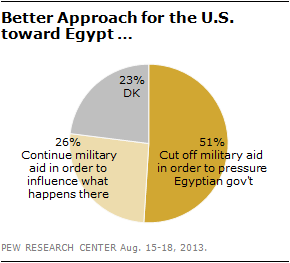Draw attention to some important aspects in this diagram. The value of the smallest segment is 23. The sum of the smallest and second largest segments is not equal to the value of the largest segment. 